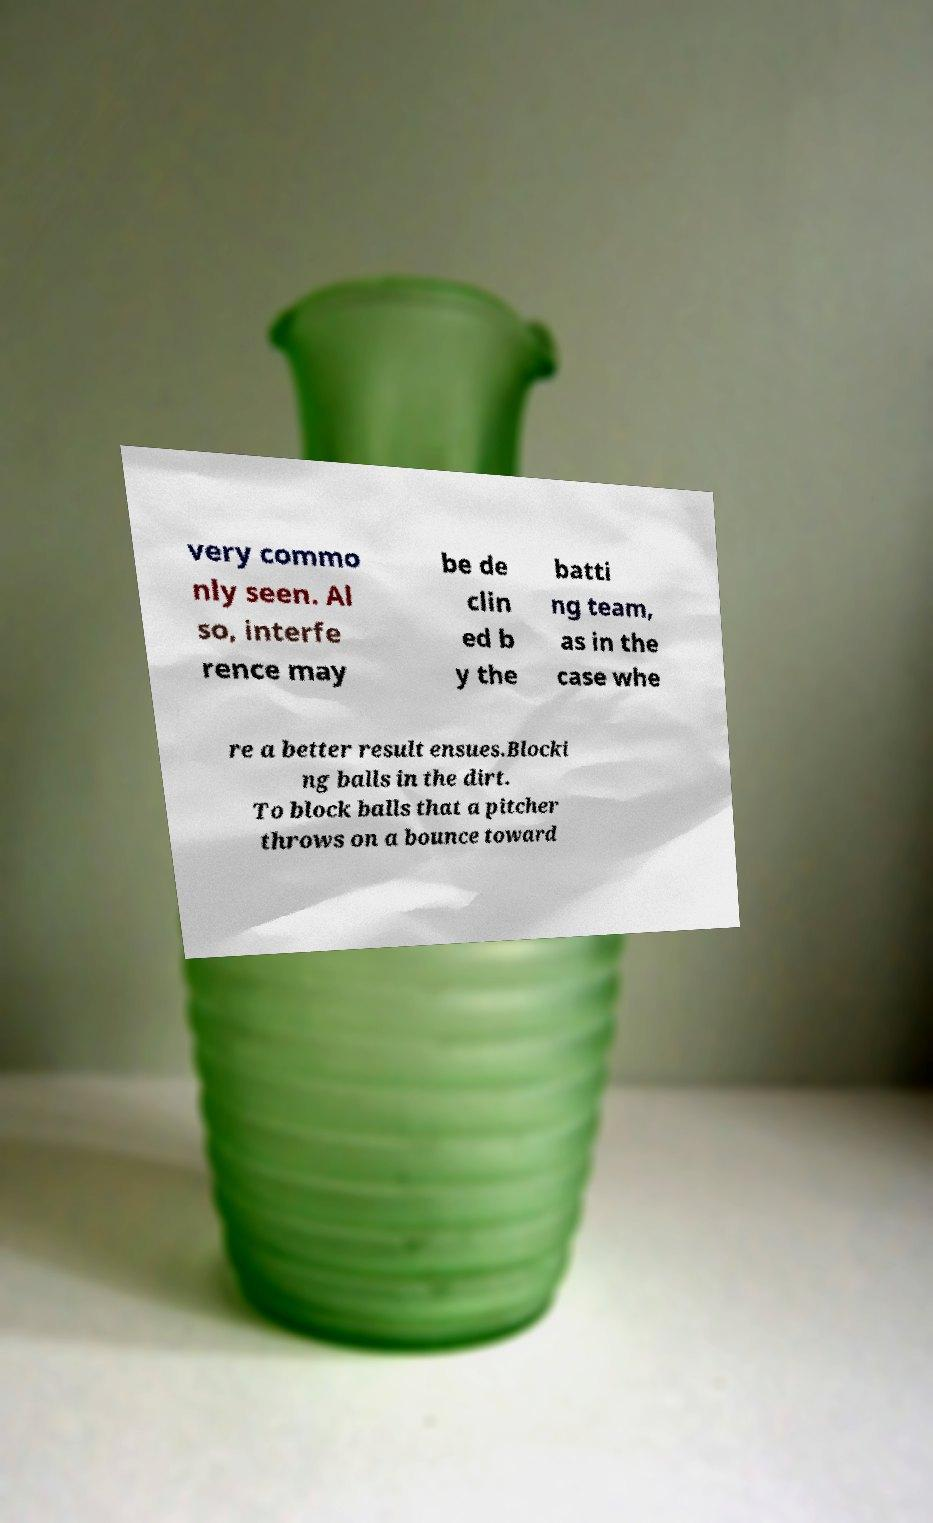Please read and relay the text visible in this image. What does it say? very commo nly seen. Al so, interfe rence may be de clin ed b y the batti ng team, as in the case whe re a better result ensues.Blocki ng balls in the dirt. To block balls that a pitcher throws on a bounce toward 